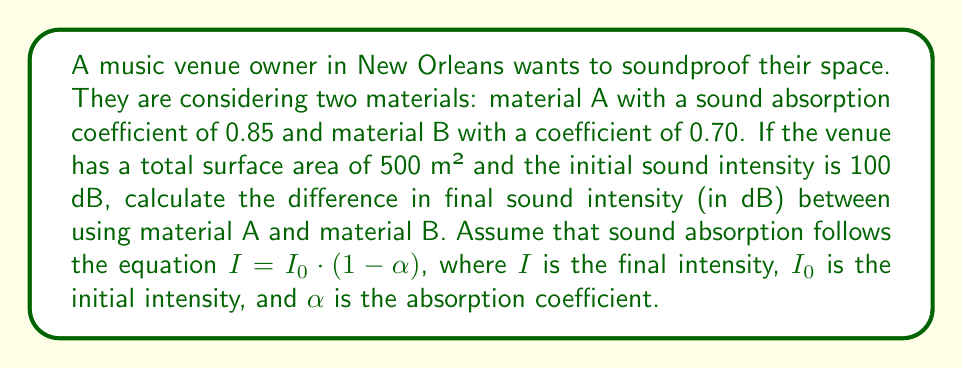Can you solve this math problem? 1. Convert initial intensity from dB to W/m²:
   $I_0 = 10^{(100 \text{ dB} / 10)} \cdot 10^{-12} \text{ W/m²} = 0.1 \text{ W/m²}$

2. Calculate final intensity for material A:
   $I_A = I_0 \cdot (1-\alpha_A) = 0.1 \cdot (1-0.85) = 0.015 \text{ W/m²}$

3. Calculate final intensity for material B:
   $I_B = I_0 \cdot (1-\alpha_B) = 0.1 \cdot (1-0.70) = 0.03 \text{ W/m²}$

4. Convert final intensities back to dB:
   $\text{dB}_A = 10 \log_{10}(I_A / 10^{-12}) = 101.76 \text{ dB}$
   $\text{dB}_B = 10 \log_{10}(I_B / 10^{-12}) = 104.77 \text{ dB}$

5. Calculate the difference in final sound intensity:
   $\Delta \text{dB} = \text{dB}_B - \text{dB}_A = 104.77 - 101.76 = 3.01 \text{ dB}$
Answer: 3.01 dB 